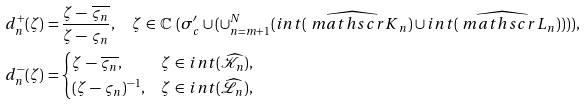Convert formula to latex. <formula><loc_0><loc_0><loc_500><loc_500>d _ { n } ^ { + } ( \zeta ) \, = & \, \frac { \zeta \, - \, \overline { \varsigma _ { n } } } { \zeta \, - \, \varsigma _ { n } } , \quad \zeta \, \in \, \mathbb { C } \ ( \sigma _ { c } ^ { \prime } \cup ( \cup _ { n = m + 1 } ^ { N } ( i n t ( \widehat { \ m a t h s c r { K } } _ { n } ) \cup i n t ( \widehat { \ m a t h s c r { L } } _ { n } ) ) ) ) , \\ d _ { n } ^ { - } ( \zeta ) \, = & \begin{cases} \zeta \, - \, \overline { \varsigma _ { n } } , & \text {$\zeta \, \in \, int (\widehat{\mathscr{K}}_{n})$,} \\ ( \zeta \, - \, \varsigma _ { n } ) ^ { - 1 } , & \text {$\zeta \, \in \, int (\widehat{\mathscr{L}}_{n})$,} \end{cases}</formula> 